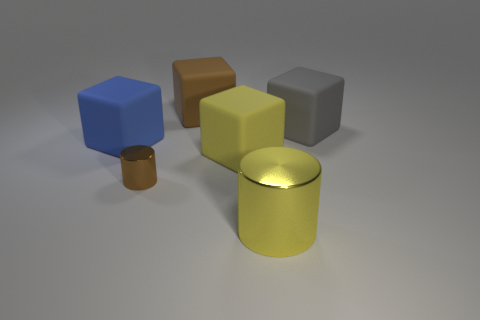There is a brown thing that is the same material as the large yellow cube; what is its shape?
Offer a terse response. Cube. There is a small metallic cylinder; is it the same color as the big block that is behind the gray rubber cube?
Your response must be concise. Yes. Are there fewer small metallic things behind the large gray cube than big gray blocks?
Your response must be concise. Yes. What material is the tiny thing that is behind the big yellow cylinder?
Make the answer very short. Metal. What number of other things are the same size as the gray matte thing?
Offer a terse response. 4. Does the yellow metal object have the same size as the rubber thing that is behind the gray cube?
Give a very brief answer. Yes. The big matte thing in front of the blue object that is on the left side of the big yellow cube that is left of the big yellow cylinder is what shape?
Keep it short and to the point. Cube. Is the number of small red things less than the number of large gray blocks?
Your answer should be very brief. Yes. Are there any big yellow blocks in front of the large cylinder?
Keep it short and to the point. No. There is a object that is both in front of the big yellow rubber thing and on the right side of the brown metal thing; what is its shape?
Your response must be concise. Cylinder. 